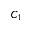Convert formula to latex. <formula><loc_0><loc_0><loc_500><loc_500>C _ { 1 }</formula> 